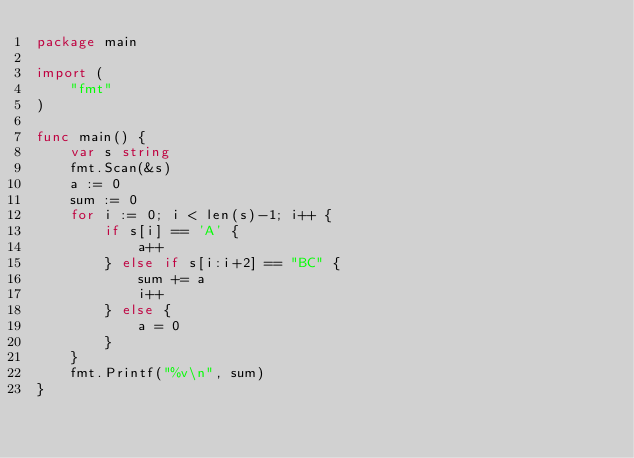<code> <loc_0><loc_0><loc_500><loc_500><_Go_>package main

import (
	"fmt"
)

func main() {
	var s string
	fmt.Scan(&s)
	a := 0
	sum := 0
	for i := 0; i < len(s)-1; i++ {
		if s[i] == 'A' {
			a++
		} else if s[i:i+2] == "BC" {
			sum += a
			i++
		} else {
			a = 0
		}
	}
	fmt.Printf("%v\n", sum)
}
</code> 